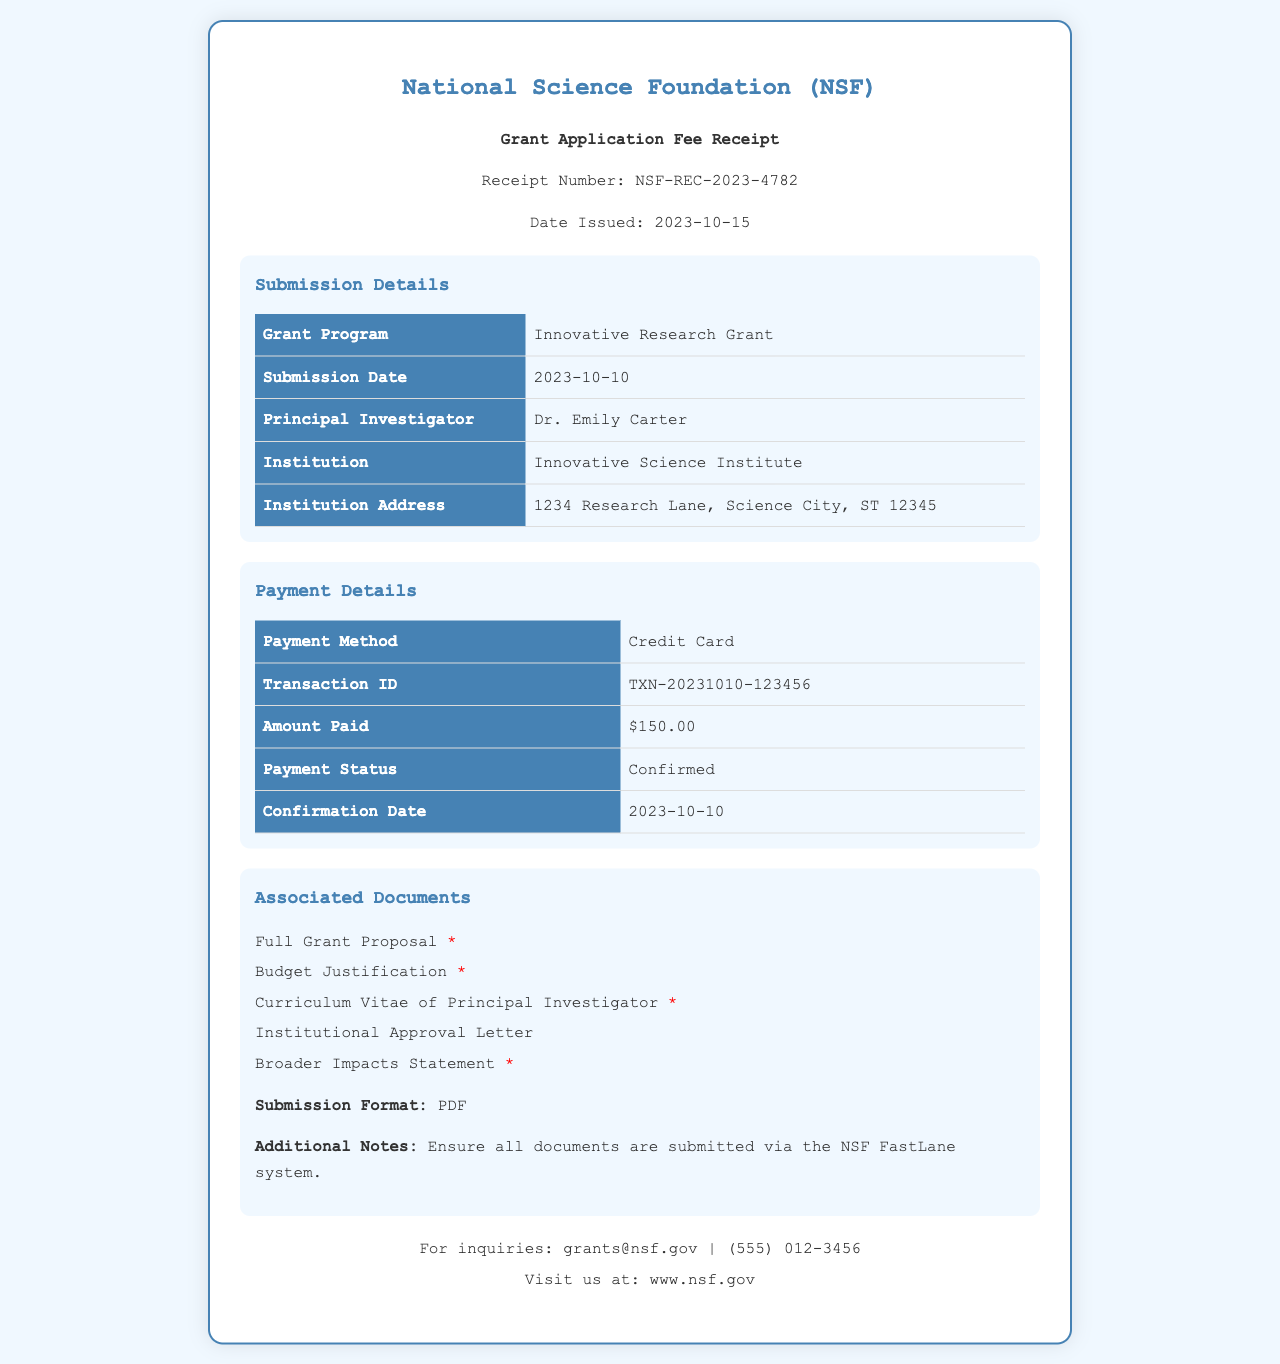What is the receipt number? The receipt number is mentioned in the header section of the document as NSF-REC-2023-4782.
Answer: NSF-REC-2023-4782 What is the amount paid? The amount paid is stated under Payment Details as $150.00.
Answer: $150.00 When was the payment confirmed? The payment status and confirmation date are provided in the Payment Details section, which states it was confirmed on 2023-10-10.
Answer: 2023-10-10 Who is the Principal Investigator? The Principal Investigator's name is found in the Submission Details section and is listed as Dr. Emily Carter.
Answer: Dr. Emily Carter What is the submission date? The submission date can be found in the Submission Details section, which shows it was submitted on 2023-10-10.
Answer: 2023-10-10 What is the required submission format for associated documents? The required submission format is mentioned in the Associated Documents section as PDF.
Answer: PDF Name one of the required documents for submission. The document list in the Associated Documents section includes several required items, one of which is the Full Grant Proposal.
Answer: Full Grant Proposal What payment method was used? The payment method is specified in the Payment Details section as Credit Card.
Answer: Credit Card What is the email address for inquiries? The email address is given in the footer of the document as grants@nsf.gov.
Answer: grants@nsf.gov 